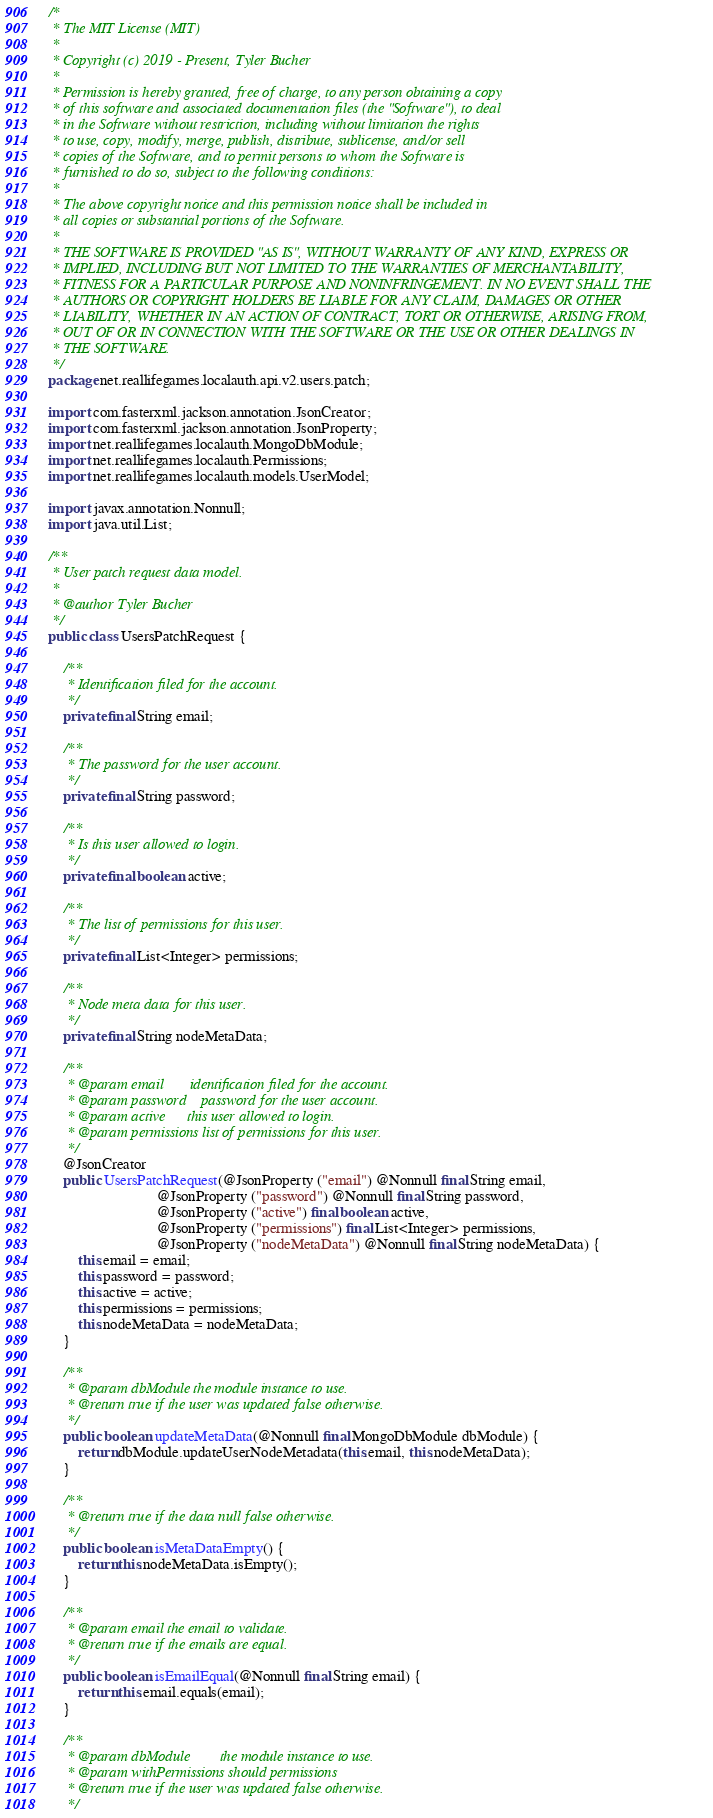Convert code to text. <code><loc_0><loc_0><loc_500><loc_500><_Java_>/*
 * The MIT License (MIT)
 *
 * Copyright (c) 2019 - Present, Tyler Bucher
 *
 * Permission is hereby granted, free of charge, to any person obtaining a copy
 * of this software and associated documentation files (the "Software"), to deal
 * in the Software without restriction, including without limitation the rights
 * to use, copy, modify, merge, publish, distribute, sublicense, and/or sell
 * copies of the Software, and to permit persons to whom the Software is
 * furnished to do so, subject to the following conditions:
 *
 * The above copyright notice and this permission notice shall be included in
 * all copies or substantial portions of the Software.
 *
 * THE SOFTWARE IS PROVIDED "AS IS", WITHOUT WARRANTY OF ANY KIND, EXPRESS OR
 * IMPLIED, INCLUDING BUT NOT LIMITED TO THE WARRANTIES OF MERCHANTABILITY,
 * FITNESS FOR A PARTICULAR PURPOSE AND NONINFRINGEMENT. IN NO EVENT SHALL THE
 * AUTHORS OR COPYRIGHT HOLDERS BE LIABLE FOR ANY CLAIM, DAMAGES OR OTHER
 * LIABILITY, WHETHER IN AN ACTION OF CONTRACT, TORT OR OTHERWISE, ARISING FROM,
 * OUT OF OR IN CONNECTION WITH THE SOFTWARE OR THE USE OR OTHER DEALINGS IN
 * THE SOFTWARE.
 */
package net.reallifegames.localauth.api.v2.users.patch;

import com.fasterxml.jackson.annotation.JsonCreator;
import com.fasterxml.jackson.annotation.JsonProperty;
import net.reallifegames.localauth.MongoDbModule;
import net.reallifegames.localauth.Permissions;
import net.reallifegames.localauth.models.UserModel;

import javax.annotation.Nonnull;
import java.util.List;

/**
 * User patch request data model.
 *
 * @author Tyler Bucher
 */
public class UsersPatchRequest {

    /**
     * Identification filed for the account.
     */
    private final String email;

    /**
     * The password for the user account.
     */
    private final String password;

    /**
     * Is this user allowed to login.
     */
    private final boolean active;

    /**
     * The list of permissions for this user.
     */
    private final List<Integer> permissions;

    /**
     * Node meta data for this user.
     */
    private final String nodeMetaData;

    /**
     * @param email       identification filed for the account.
     * @param password    password for the user account.
     * @param active      this user allowed to login.
     * @param permissions list of permissions for this user.
     */
    @JsonCreator
    public UsersPatchRequest(@JsonProperty ("email") @Nonnull final String email,
                             @JsonProperty ("password") @Nonnull final String password,
                             @JsonProperty ("active") final boolean active,
                             @JsonProperty ("permissions") final List<Integer> permissions,
                             @JsonProperty ("nodeMetaData") @Nonnull final String nodeMetaData) {
        this.email = email;
        this.password = password;
        this.active = active;
        this.permissions = permissions;
        this.nodeMetaData = nodeMetaData;
    }

    /**
     * @param dbModule the module instance to use.
     * @return true if the user was updated false otherwise.
     */
    public boolean updateMetaData(@Nonnull final MongoDbModule dbModule) {
        return dbModule.updateUserNodeMetadata(this.email, this.nodeMetaData);
    }

    /**
     * @return true if the data null false otherwise.
     */
    public boolean isMetaDataEmpty() {
        return this.nodeMetaData.isEmpty();
    }

    /**
     * @param email the email to validate.
     * @return true if the emails are equal.
     */
    public boolean isEmailEqual(@Nonnull final String email) {
        return this.email.equals(email);
    }

    /**
     * @param dbModule        the module instance to use.
     * @param withPermissions should permissions
     * @return true if the user was updated false otherwise.
     */</code> 